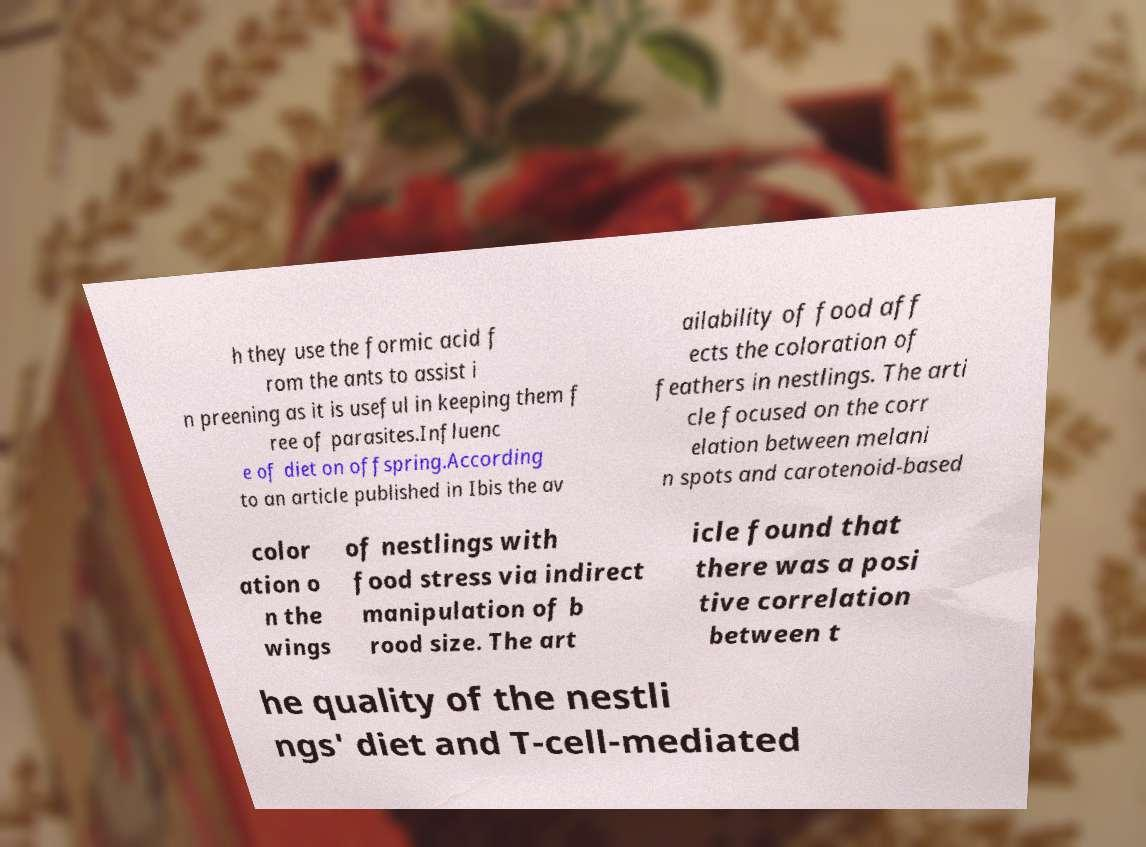Could you assist in decoding the text presented in this image and type it out clearly? h they use the formic acid f rom the ants to assist i n preening as it is useful in keeping them f ree of parasites.Influenc e of diet on offspring.According to an article published in Ibis the av ailability of food aff ects the coloration of feathers in nestlings. The arti cle focused on the corr elation between melani n spots and carotenoid-based color ation o n the wings of nestlings with food stress via indirect manipulation of b rood size. The art icle found that there was a posi tive correlation between t he quality of the nestli ngs' diet and T-cell-mediated 